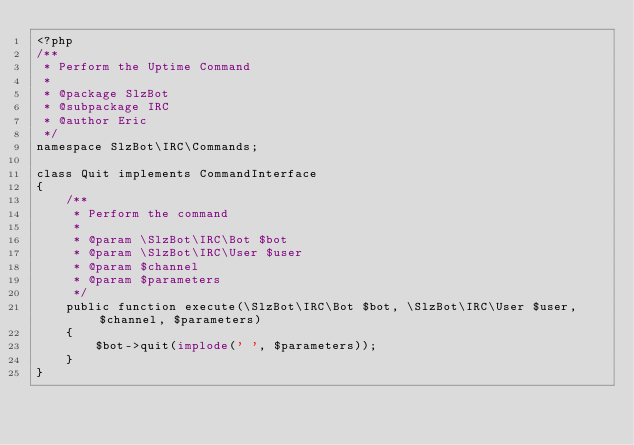<code> <loc_0><loc_0><loc_500><loc_500><_PHP_><?php
/**
 * Perform the Uptime Command
 *
 * @package SlzBot
 * @subpackage IRC
 * @author Eric
 */
namespace SlzBot\IRC\Commands;

class Quit implements CommandInterface
{
    /**
     * Perform the command
     *
     * @param \SlzBot\IRC\Bot $bot
     * @param \SlzBot\IRC\User $user
     * @param $channel
     * @param $parameters
     */
    public function execute(\SlzBot\IRC\Bot $bot, \SlzBot\IRC\User $user, $channel, $parameters)
    {
        $bot->quit(implode(' ', $parameters));
    }
}</code> 